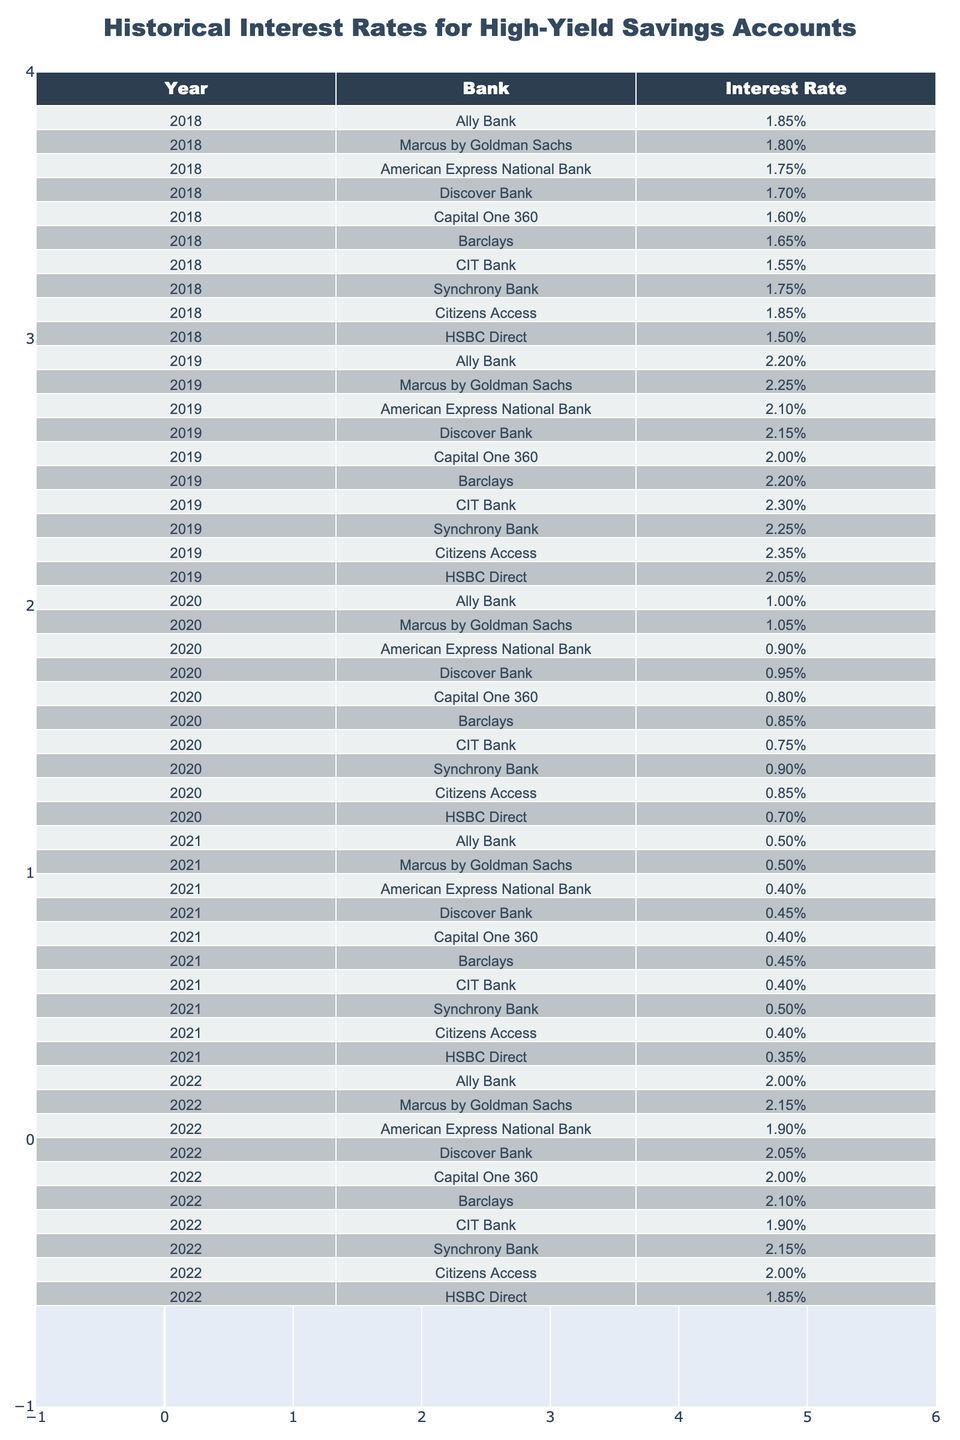What was the highest interest rate offered by Ally Bank in 2022? According to the table, Ally Bank offered an interest rate of 2.00% in 2022. This is the only value listed for that year, as seen in the 2022 row for Ally Bank.
Answer: 2.00% Which bank consistently offered the highest interest rate from 2018 to 2019? By examining the data for 2018 and 2019, Citizens Access had the highest interest rate of 1.85% in 2018 and the highest rate of 2.35% in 2019, making it the bank that consistently offered the highest rates during these years.
Answer: Citizens Access What was the average interest rate of Discover Bank from 2018 to 2022? The interest rates for Discover Bank over these years are: 1.70% (2018), 2.15% (2019), 0.95% (2020), 0.45% (2021), and 2.05% (2022). Adding these gives 1.70 + 2.15 + 0.95 + 0.45 + 2.05 = 7.30. Dividing by 5 (the number of years) results in an average of 1.46%.
Answer: 1.46% Did HSBC Direct offer more than 1.00% interest in any year from 2018 to 2022? By reviewing the interest rates for HSBC Direct, they offered 1.50% in 2018, 2.05% in 2019, 0.70% in 2020, 0.35% in 2021, and 1.85% in 2022. This indicates that HSBC Direct offered more than 1.00% in 2018, 2019, and 2022.
Answer: Yes What was the difference in interest rates between the highest and lowest rates offered by Capital One 360 from 2018 to 2022? The highest interest rate for Capital One 360 was 2.00% in 2022, and the lowest was 0.80% in 2020. The difference can be calculated as 2.00% - 0.80% = 1.20%.
Answer: 1.20% Which bank had the largest increase in interest rates from 2019 to 2022? To determine this, we compare the rates for 2019 and 2022. For example, CIT Bank had a rate of 2.30% in 2019 and 1.90% in 2022. However, Synchrony Bank rose from 2.25% in 2019 to 2.15% in 2022. The largest increase is actually the decrease observed in these banks. Therefore, we find that no bank showed an increase across these years, only decreases.
Answer: None How many banks had an interest rate of 0.90% or lower in 2021? In 2021, the interest rates were: Ally Bank (0.50%), Marcus by Goldman Sachs (0.50%), American Express National Bank (0.40%), Discover Bank (0.45%), Capital One 360 (0.40%), Barclays (0.45%), CIT Bank (0.40%), Synchrony Bank (0.50%), Citizens Access (0.40%), and HSBC Direct (0.35%). Counting those with 0.90% or lower gives 10 banks.
Answer: 10 What was the trend in interest rates for high-yield savings accounts from 2018 to 2021? Analyzing the data, the trend shows a general decline in interest rates from 2018 to 2021. In 2018, rates were mainly above 1.50%, but by 2021, the rates had dropped significantly, with the majority falling below 1.00%. This indicates a downward trend over these years.
Answer: Downward trend Which bank had the highest interest rate in 2020? The data shows that Ally Bank offered the highest interest rate in 2020 at 1.00%. This can be found by checking each bank's rate for that year.
Answer: Ally Bank 